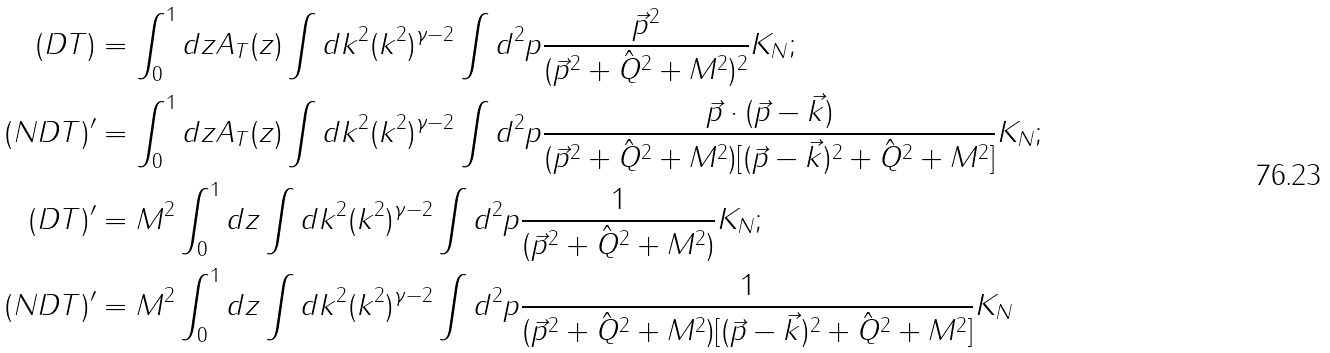Convert formula to latex. <formula><loc_0><loc_0><loc_500><loc_500>( D T ) & = \int _ { 0 } ^ { 1 } d z A _ { T } ( z ) \int d k ^ { 2 } ( k ^ { 2 } ) ^ { \gamma - 2 } \int d ^ { 2 } p \frac { \vec { p } ^ { 2 } } { ( \vec { p } ^ { 2 } + \hat { Q } ^ { 2 } + M ^ { 2 } ) ^ { 2 } } K _ { N } ; \\ ( N D T ) ^ { \prime } & = \int _ { 0 } ^ { 1 } d z A _ { T } ( z ) \int d k ^ { 2 } ( k ^ { 2 } ) ^ { \gamma - 2 } \int d ^ { 2 } p \frac { \vec { p } \cdot ( \vec { p } - \vec { k } ) } { ( \vec { p } ^ { 2 } + \hat { Q } ^ { 2 } + M ^ { 2 } ) [ ( \vec { p } - \vec { k } ) ^ { 2 } + \hat { Q } ^ { 2 } + M ^ { 2 } ] } K _ { N } ; \\ ( D T ) ^ { \prime } & = M ^ { 2 } \int _ { 0 } ^ { 1 } d z \int d k ^ { 2 } ( k ^ { 2 } ) ^ { \gamma - 2 } \int d ^ { 2 } p \frac { 1 } { ( \vec { p } ^ { 2 } + \hat { Q } ^ { 2 } + M ^ { 2 } ) } K _ { N } ; \\ ( N D T ) ^ { \prime } & = M ^ { 2 } \int _ { 0 } ^ { 1 } d z \int d k ^ { 2 } ( k ^ { 2 } ) ^ { \gamma - 2 } \int d ^ { 2 } p \frac { 1 } { ( \vec { p } ^ { 2 } + \hat { Q } ^ { 2 } + M ^ { 2 } ) [ ( \vec { p } - \vec { k } ) ^ { 2 } + \hat { Q } ^ { 2 } + M ^ { 2 } ] } K _ { N }</formula> 